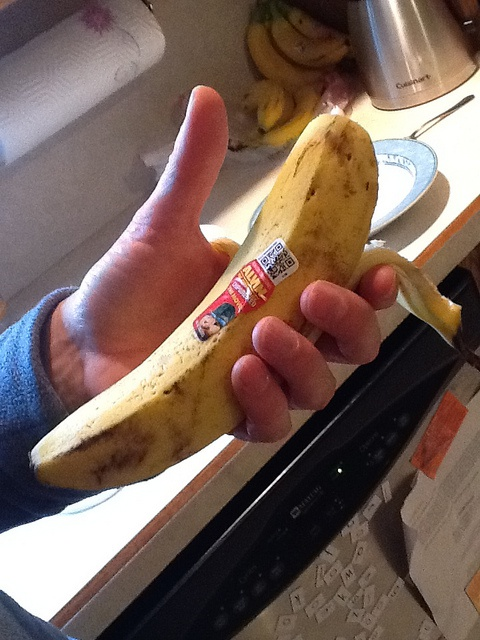Describe the objects in this image and their specific colors. I can see people in brown, maroon, black, and gray tones, banana in brown, maroon, and ivory tones, banana in black, maroon, and brown tones, banana in brown, maroon, olive, and black tones, and fork in brown, gray, ivory, and darkgray tones in this image. 